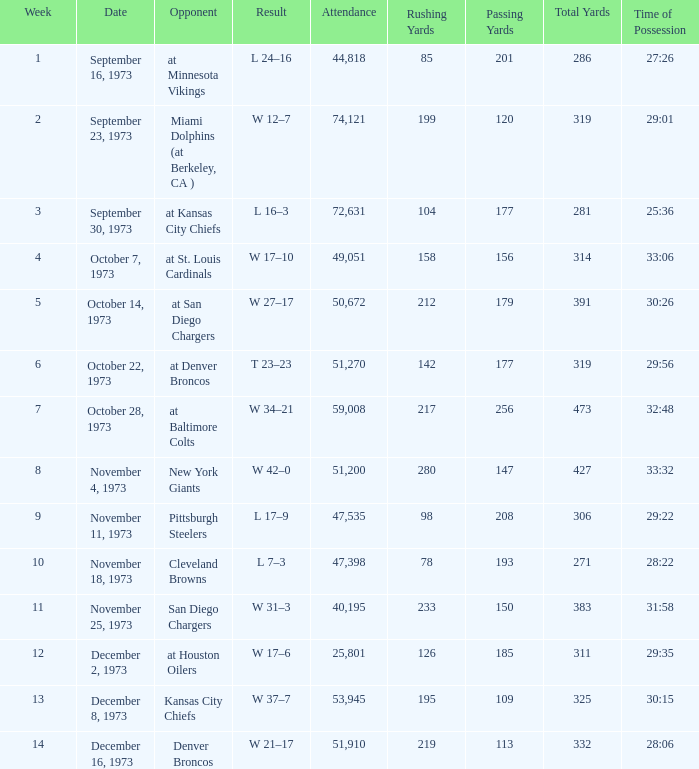What is the highest number in attendance against the game at Kansas City Chiefs? 72631.0. 